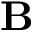<formula> <loc_0><loc_0><loc_500><loc_500>B</formula> 